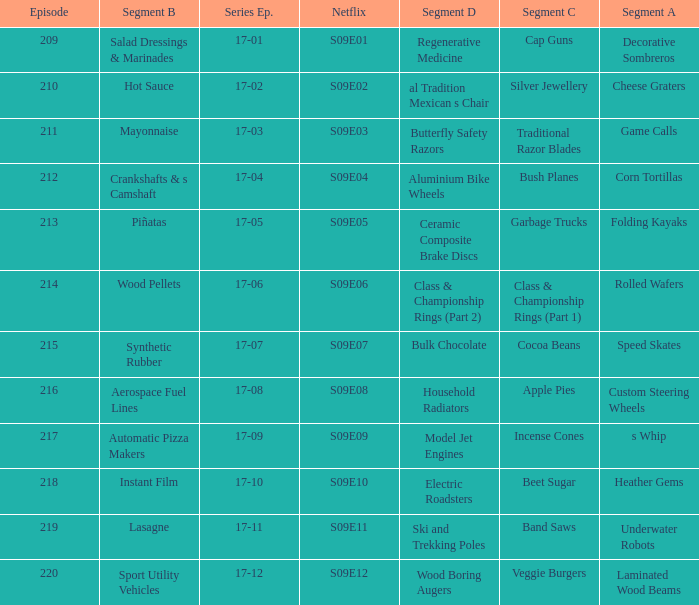How many segments involve wood boring augers Laminated Wood Beams. 